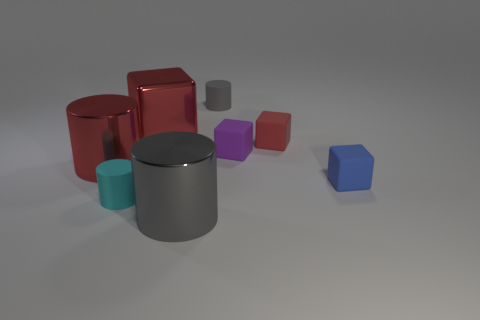Add 1 large rubber objects. How many objects exist? 9 Subtract all large red metallic cylinders. How many cylinders are left? 3 Subtract all brown cubes. Subtract all red balls. How many cubes are left? 4 Add 8 tiny cyan objects. How many tiny cyan objects are left? 9 Add 7 small gray matte cylinders. How many small gray matte cylinders exist? 8 Subtract 0 brown blocks. How many objects are left? 8 Subtract all cyan objects. Subtract all red cylinders. How many objects are left? 6 